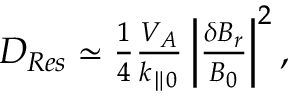<formula> <loc_0><loc_0><loc_500><loc_500>\begin{array} { r } { D _ { R e s } \simeq \frac { 1 } { 4 } \frac { V _ { A } } { k _ { \| 0 } } \left | \frac { \delta B _ { r } } { B _ { 0 } } \right | ^ { 2 } , } \end{array}</formula> 